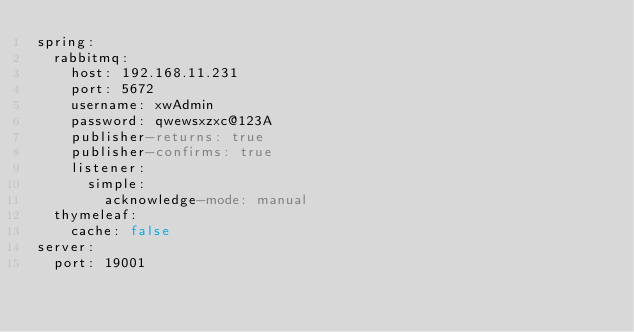<code> <loc_0><loc_0><loc_500><loc_500><_YAML_>spring:
  rabbitmq:
    host: 192.168.11.231
    port: 5672
    username: xwAdmin
    password: qwewsxzxc@123A
    publisher-returns: true
    publisher-confirms: true
    listener:
      simple:
        acknowledge-mode: manual
  thymeleaf:
    cache: false
server:
  port: 19001
</code> 